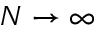<formula> <loc_0><loc_0><loc_500><loc_500>N \to \infty</formula> 